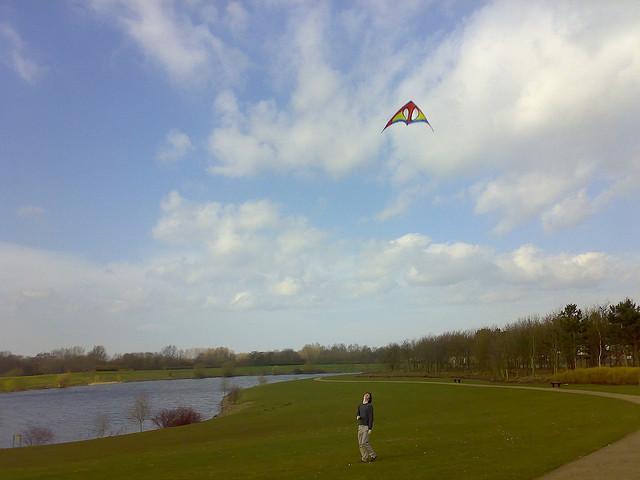How many boats are in the water?
Give a very brief answer. 0. How many kites are in the sky?
Give a very brief answer. 1. How many kites do you see?
Give a very brief answer. 1. How many little girls can be seen?
Give a very brief answer. 0. How many of these buses are big red tall boys with two floors nice??
Give a very brief answer. 0. 